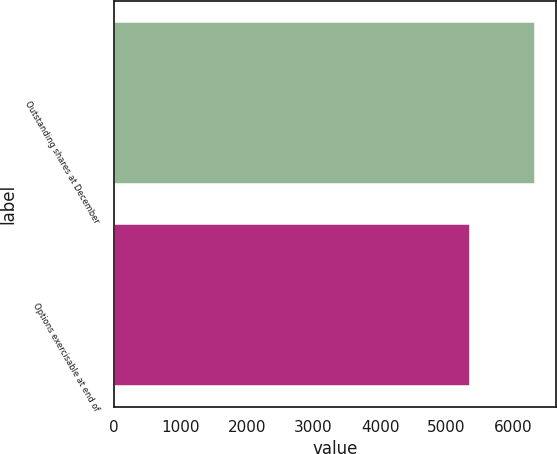<chart> <loc_0><loc_0><loc_500><loc_500><bar_chart><fcel>Outstanding shares at December<fcel>Options exercisable at end of<nl><fcel>6332<fcel>5360<nl></chart> 